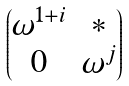Convert formula to latex. <formula><loc_0><loc_0><loc_500><loc_500>\begin{pmatrix} \omega ^ { 1 + i } & * \\ 0 & \omega ^ { j } \end{pmatrix}</formula> 